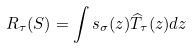<formula> <loc_0><loc_0><loc_500><loc_500>R _ { \tau } ( S ) = \int s _ { \sigma } ( z ) \widehat { T } _ { \tau } ( z ) d z</formula> 